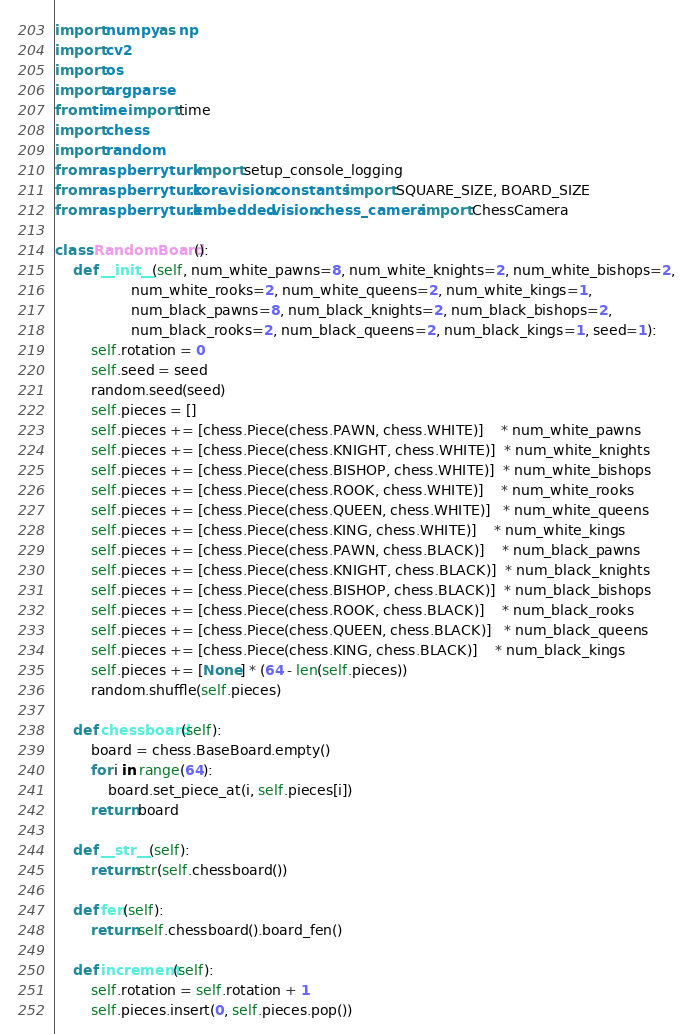<code> <loc_0><loc_0><loc_500><loc_500><_Python_>import numpy as np
import cv2
import os
import argparse
from time import time
import chess
import random
from raspberryturk import setup_console_logging
from raspberryturk.core.vision.constants import SQUARE_SIZE, BOARD_SIZE
from raspberryturk.embedded.vision.chess_camera import ChessCamera

class RandomBoard():
    def __init__(self, num_white_pawns=8, num_white_knights=2, num_white_bishops=2,
                 num_white_rooks=2, num_white_queens=2, num_white_kings=1,
                 num_black_pawns=8, num_black_knights=2, num_black_bishops=2,
                 num_black_rooks=2, num_black_queens=2, num_black_kings=1, seed=1):
        self.rotation = 0
        self.seed = seed
        random.seed(seed)
        self.pieces = []
        self.pieces += [chess.Piece(chess.PAWN, chess.WHITE)]    * num_white_pawns
        self.pieces += [chess.Piece(chess.KNIGHT, chess.WHITE)]  * num_white_knights
        self.pieces += [chess.Piece(chess.BISHOP, chess.WHITE)]  * num_white_bishops
        self.pieces += [chess.Piece(chess.ROOK, chess.WHITE)]    * num_white_rooks
        self.pieces += [chess.Piece(chess.QUEEN, chess.WHITE)]   * num_white_queens
        self.pieces += [chess.Piece(chess.KING, chess.WHITE)]    * num_white_kings
        self.pieces += [chess.Piece(chess.PAWN, chess.BLACK)]    * num_black_pawns
        self.pieces += [chess.Piece(chess.KNIGHT, chess.BLACK)]  * num_black_knights
        self.pieces += [chess.Piece(chess.BISHOP, chess.BLACK)]  * num_black_bishops
        self.pieces += [chess.Piece(chess.ROOK, chess.BLACK)]    * num_black_rooks
        self.pieces += [chess.Piece(chess.QUEEN, chess.BLACK)]   * num_black_queens
        self.pieces += [chess.Piece(chess.KING, chess.BLACK)]    * num_black_kings
        self.pieces += [None] * (64 - len(self.pieces))
        random.shuffle(self.pieces)

    def chessboard(self):
        board = chess.BaseBoard.empty()
        for i in range(64):
            board.set_piece_at(i, self.pieces[i])
        return board

    def __str__(self):
        return str(self.chessboard())

    def fen(self):
        return self.chessboard().board_fen()

    def increment(self):
        self.rotation = self.rotation + 1
        self.pieces.insert(0, self.pieces.pop())
</code> 